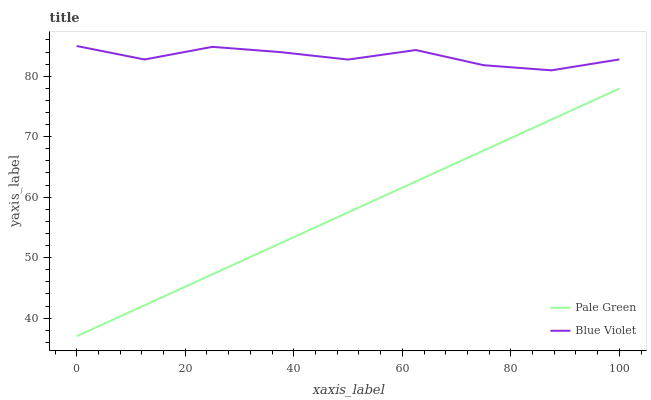Does Pale Green have the minimum area under the curve?
Answer yes or no. Yes. Does Blue Violet have the maximum area under the curve?
Answer yes or no. Yes. Does Blue Violet have the minimum area under the curve?
Answer yes or no. No. Is Pale Green the smoothest?
Answer yes or no. Yes. Is Blue Violet the roughest?
Answer yes or no. Yes. Is Blue Violet the smoothest?
Answer yes or no. No. Does Pale Green have the lowest value?
Answer yes or no. Yes. Does Blue Violet have the lowest value?
Answer yes or no. No. Does Blue Violet have the highest value?
Answer yes or no. Yes. Is Pale Green less than Blue Violet?
Answer yes or no. Yes. Is Blue Violet greater than Pale Green?
Answer yes or no. Yes. Does Pale Green intersect Blue Violet?
Answer yes or no. No. 